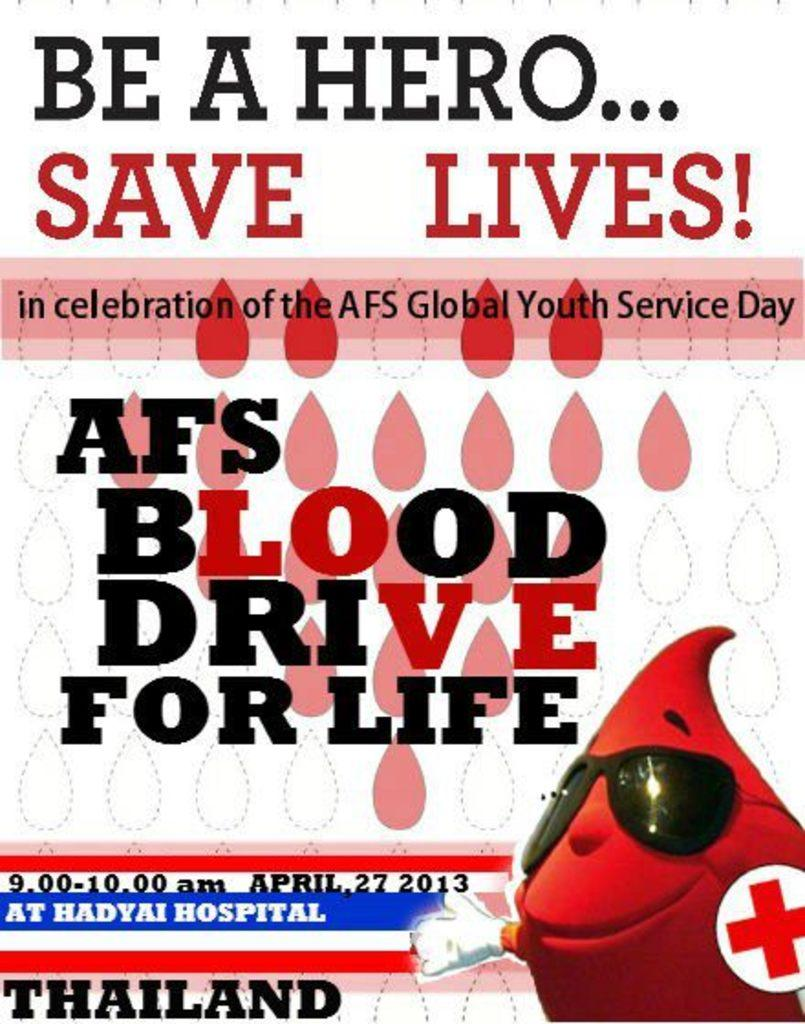What is present in the image that contains information or a message? There is a poster in the image that contains text. Can you describe the content of the poster? The poster contains text, but we cannot determine the specific message from the provided facts. What type of image is located in the bottom right side of the image? There is a cartoon picture in the bottom right side of the image. What type of pain is the person experiencing in the image? There is no person present in the image, and therefore no indication of any pain being experienced. 